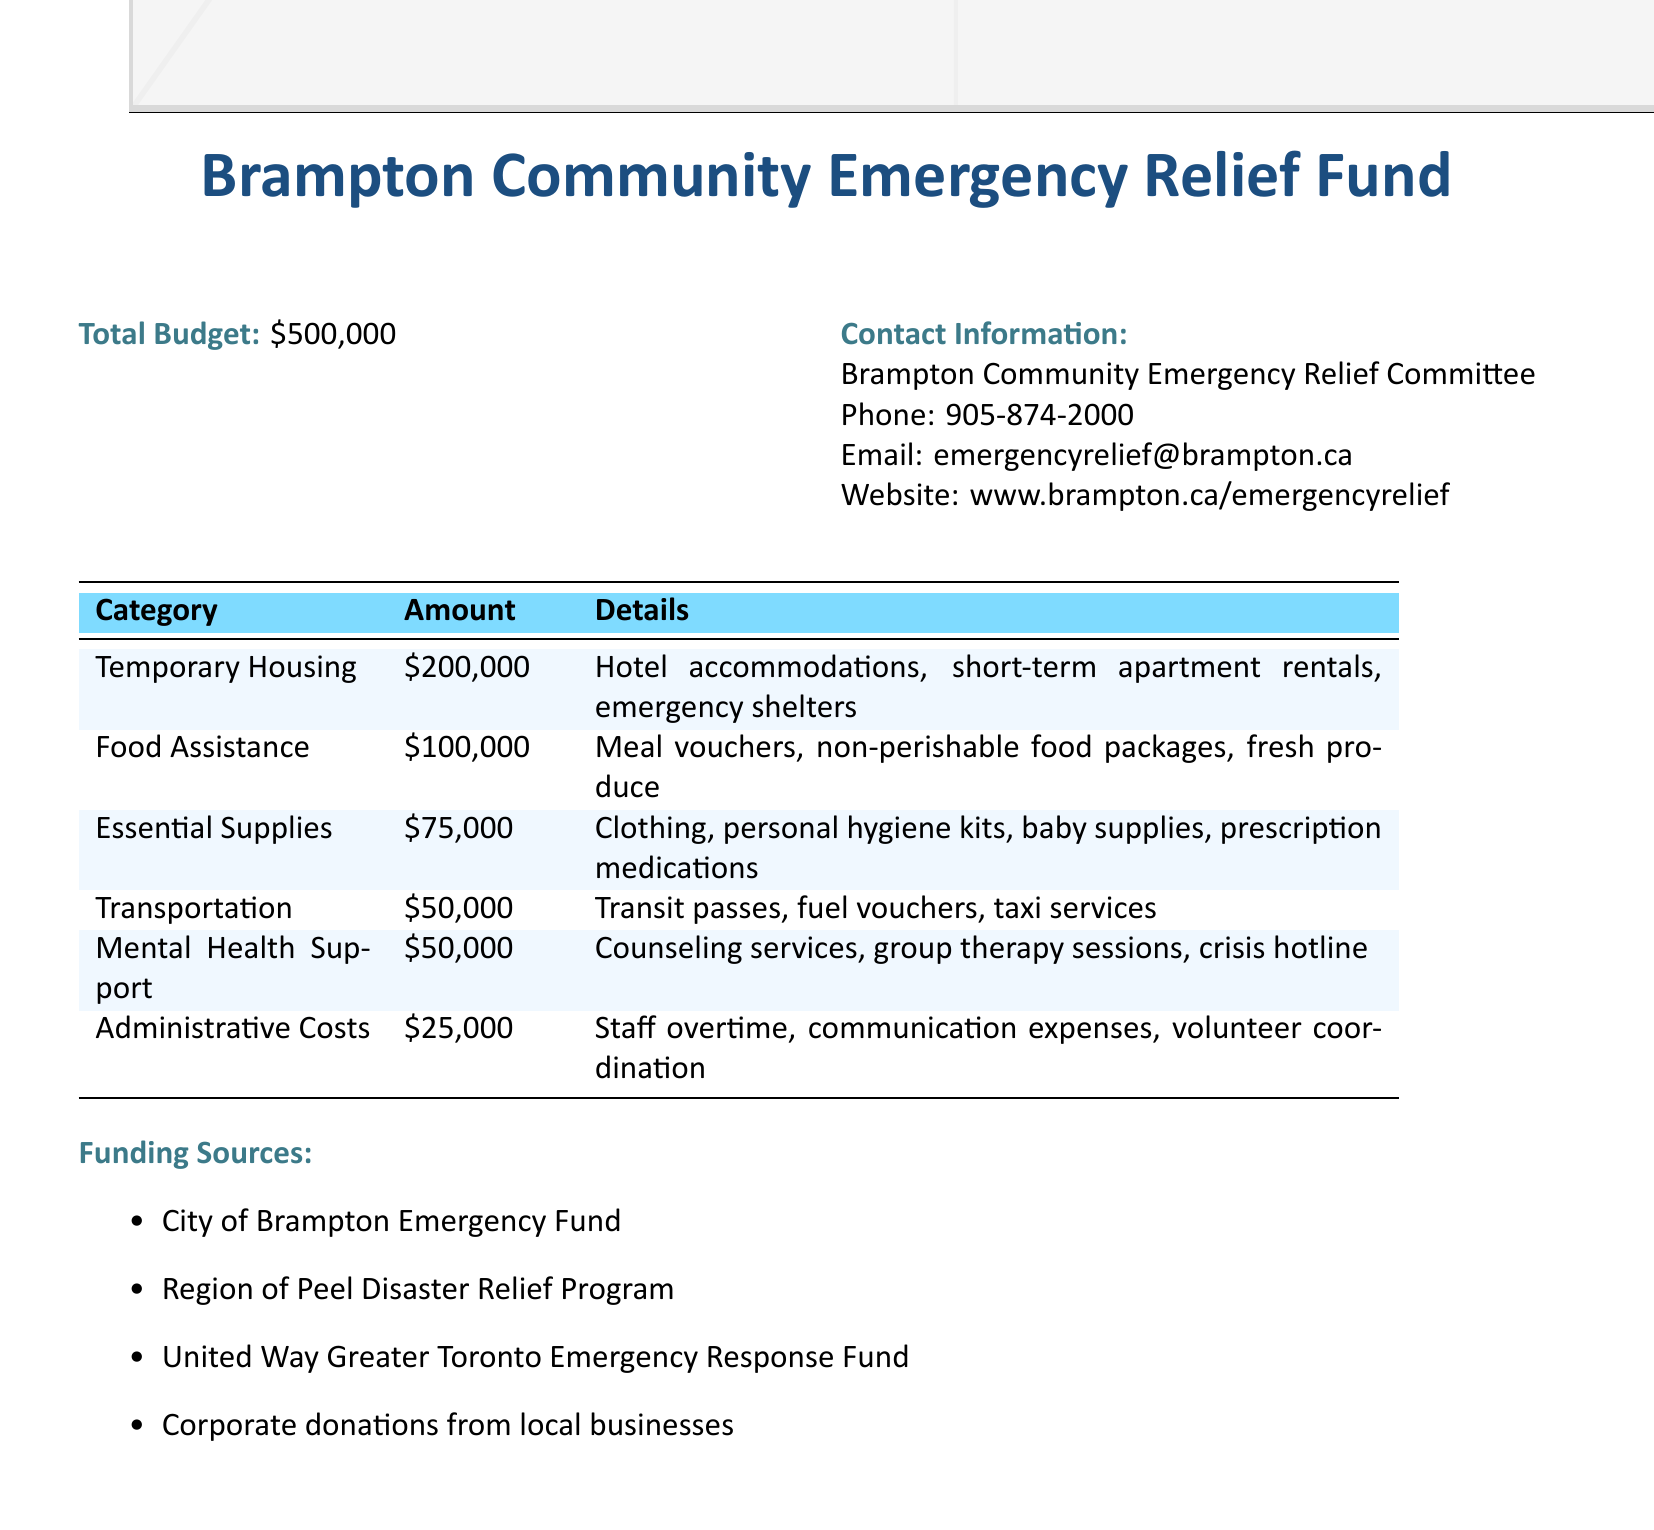What is the total budget? The total budget is explicitly stated in the document, which is $500,000.
Answer: $500,000 How much is allocated for temporary housing? The allocation for temporary housing is found under the corresponding category in the budget table.
Answer: $200,000 What is the amount dedicated to food assistance? The document outlines food assistance, specifying the exact amount allotted in the budget.
Answer: $100,000 Which category has the lowest funding allocation? By comparing the amounts listed in the budget categories, the lowest allocation reflects administrative costs.
Answer: Administrative Costs What services are included in mental health support? The document lists counseling services, group therapy sessions, and crisis hotline under mental health support.
Answer: Counseling services, group therapy sessions, crisis hotline What is the percentage of the total budget allocated for essential supplies? The percentage is calculated by dividing the allocation for essential supplies by the total budget and multiplying by 100.
Answer: 15% Which organization provides emergency response funding? The document identifies one of the funding sources for emergency response.
Answer: United Way Greater Toronto Emergency Response Fund What type of support is included in the transportation category? The transportation category details services provided, including transit passes and fuel vouchers.
Answer: Transit passes, fuel vouchers, taxi services 